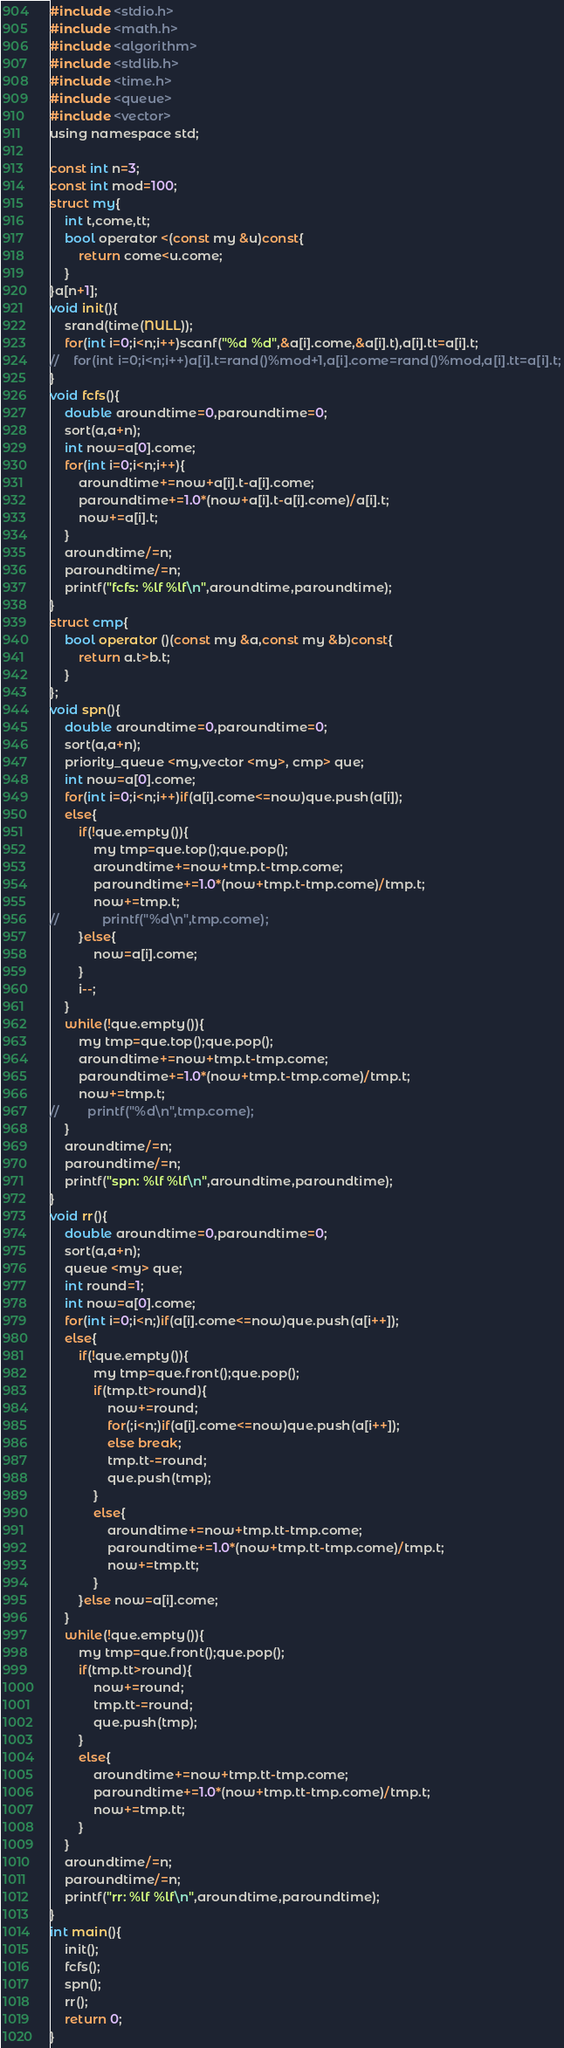<code> <loc_0><loc_0><loc_500><loc_500><_C_>#include <stdio.h>
#include <math.h>
#include <algorithm>
#include <stdlib.h>
#include <time.h>
#include <queue>
#include <vector>
using namespace std;

const int n=3;
const int mod=100;
struct my{
    int t,come,tt;
    bool operator <(const my &u)const{
        return come<u.come;
    }
}a[n+1];
void init(){
    srand(time(NULL));
    for(int i=0;i<n;i++)scanf("%d %d",&a[i].come,&a[i].t),a[i].tt=a[i].t;
//    for(int i=0;i<n;i++)a[i].t=rand()%mod+1,a[i].come=rand()%mod,a[i].tt=a[i].t;
}
void fcfs(){
    double aroundtime=0,paroundtime=0;
    sort(a,a+n);
    int now=a[0].come;
    for(int i=0;i<n;i++){
        aroundtime+=now+a[i].t-a[i].come;
        paroundtime+=1.0*(now+a[i].t-a[i].come)/a[i].t;
        now+=a[i].t;
    }
    aroundtime/=n;
    paroundtime/=n;
    printf("fcfs: %lf %lf\n",aroundtime,paroundtime);
}
struct cmp{
    bool operator ()(const my &a,const my &b)const{
        return a.t>b.t;
    }
};
void spn(){
    double aroundtime=0,paroundtime=0;
    sort(a,a+n);
    priority_queue <my,vector <my>, cmp> que;
    int now=a[0].come;
    for(int i=0;i<n;i++)if(a[i].come<=now)que.push(a[i]);
    else{
        if(!que.empty()){
            my tmp=que.top();que.pop();
            aroundtime+=now+tmp.t-tmp.come;
            paroundtime+=1.0*(now+tmp.t-tmp.come)/tmp.t;
            now+=tmp.t;
//            printf("%d\n",tmp.come);
        }else{
            now=a[i].come;
        }
        i--;
    }
    while(!que.empty()){
        my tmp=que.top();que.pop();
        aroundtime+=now+tmp.t-tmp.come;
        paroundtime+=1.0*(now+tmp.t-tmp.come)/tmp.t;
        now+=tmp.t;
//        printf("%d\n",tmp.come);
    }
    aroundtime/=n;
    paroundtime/=n;
    printf("spn: %lf %lf\n",aroundtime,paroundtime);
}
void rr(){
    double aroundtime=0,paroundtime=0;
    sort(a,a+n);
    queue <my> que;
    int round=1;
    int now=a[0].come;
    for(int i=0;i<n;)if(a[i].come<=now)que.push(a[i++]);
    else{
        if(!que.empty()){
            my tmp=que.front();que.pop();
            if(tmp.tt>round){
                now+=round;
                for(;i<n;)if(a[i].come<=now)que.push(a[i++]);
                else break;
                tmp.tt-=round;
                que.push(tmp);
            }
            else{
                aroundtime+=now+tmp.tt-tmp.come;
                paroundtime+=1.0*(now+tmp.tt-tmp.come)/tmp.t;
                now+=tmp.tt;
            }
        }else now=a[i].come;
    }
    while(!que.empty()){
        my tmp=que.front();que.pop();
        if(tmp.tt>round){
            now+=round;
            tmp.tt-=round;
            que.push(tmp);
        }
        else{
            aroundtime+=now+tmp.tt-tmp.come;
            paroundtime+=1.0*(now+tmp.tt-tmp.come)/tmp.t;
            now+=tmp.tt;
        }
    }
    aroundtime/=n;
    paroundtime/=n;
    printf("rr: %lf %lf\n",aroundtime,paroundtime);
}
int main(){
    init();
    fcfs();
    spn();
    rr();
    return 0;
}</code> 